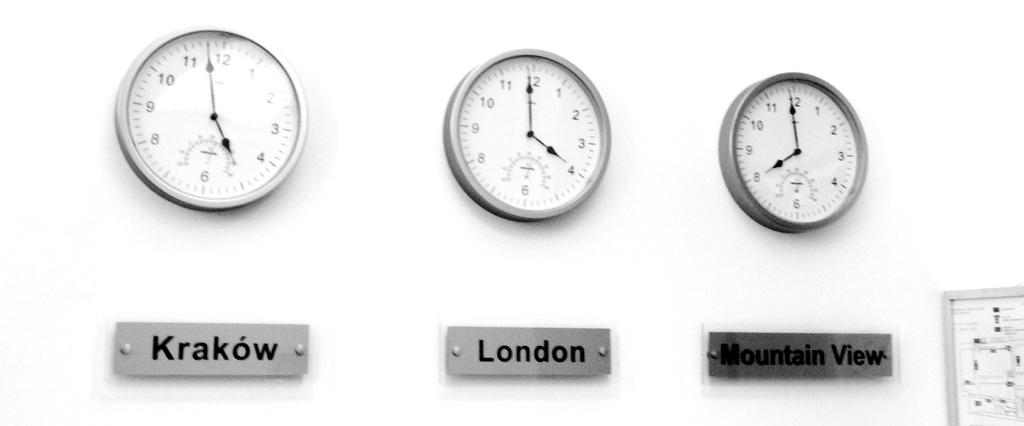<image>
Share a concise interpretation of the image provided. A clock from Krakow, London and Mountain View are hanging on a wall together. 